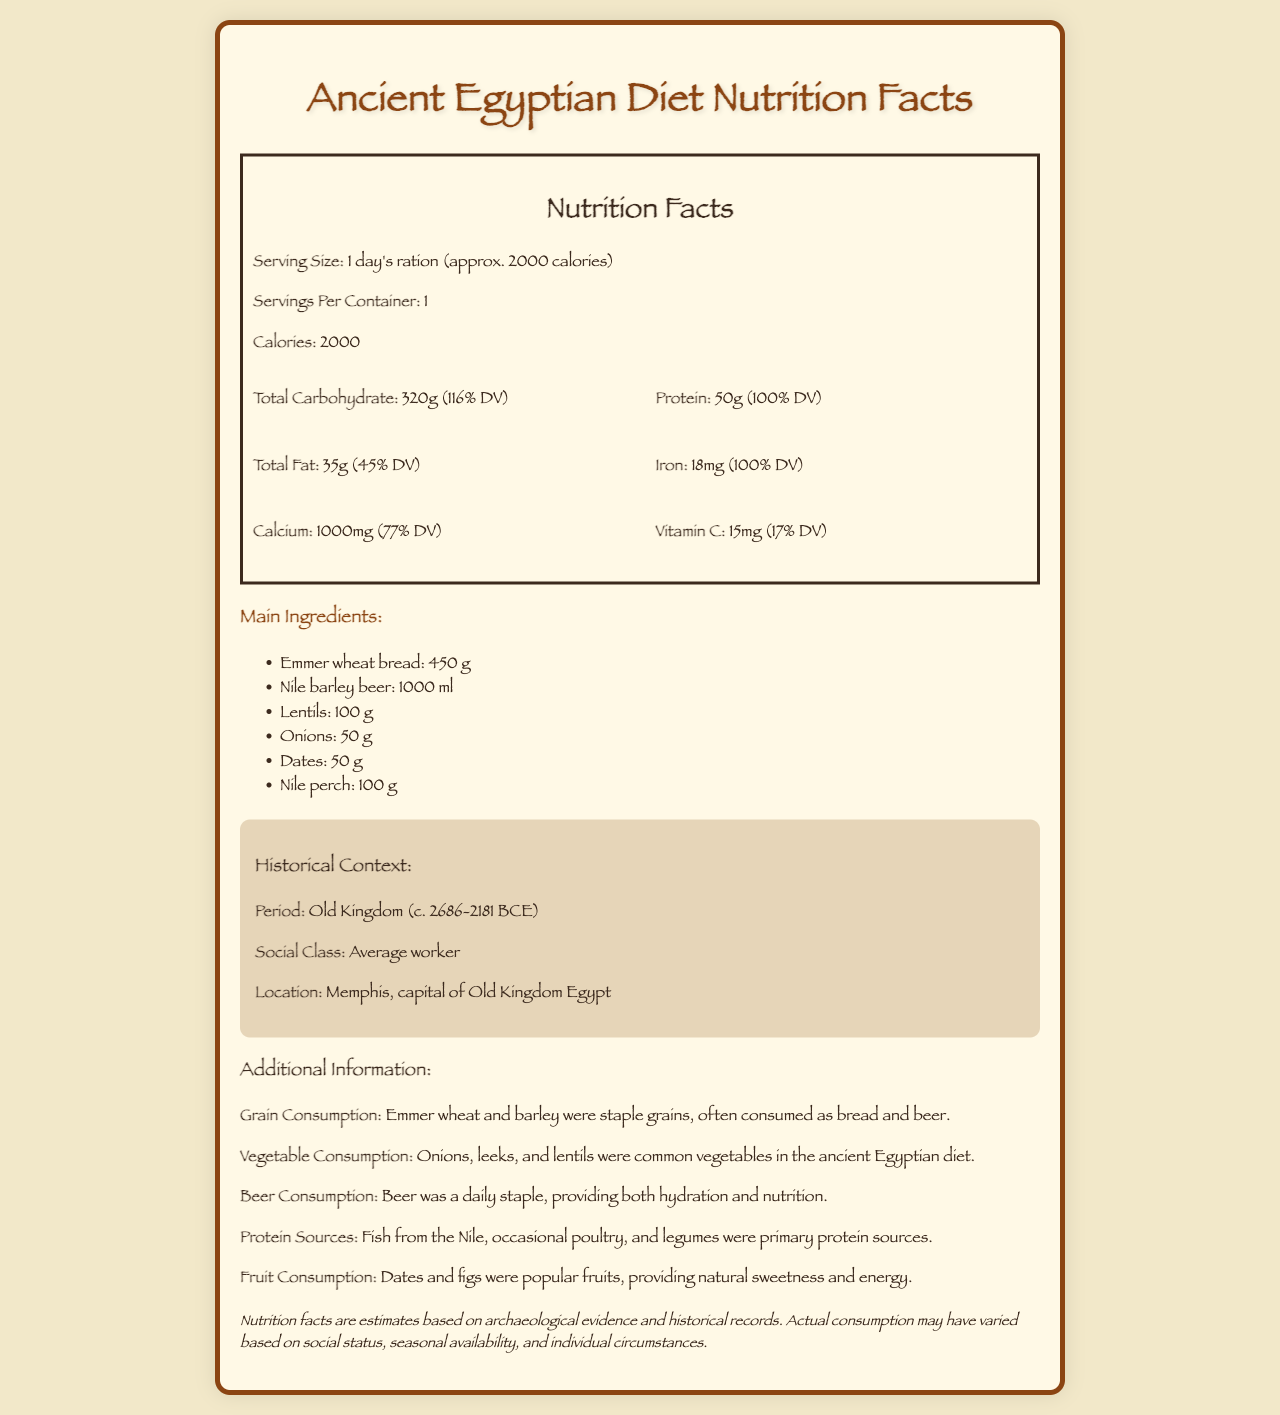who is the intended social class for this diet? The historical context section of the document specifies that this diet is for the "Average worker."
Answer: Average worker what is the serving size stated in the nutrition facts? The nutrition facts section at the top of the document mentions that the serving size is "1 day's ration (approx. 2000 calories)."
Answer: 1 day's ration (approx. 2000 calories) how much total carbohydrate is in one serving? The nutrition facts section lists the total carbohydrate content as "320 g."
Answer: 320 g what are the main protein sources mentioned? The additional information section specifies the primary protein sources as "Fish from the Nile, occasional poultry, and legumes."
Answer: Fish from the Nile, occasional poultry, and legumes which vegetable is included in the main ingredients? The ingredients list includes "Onions: 50 g."
Answer: Onions what percentage of the daily value for iron is provided by this diet? The nutrition facts section shows that the iron content in one serving is "18 mg," which is 100% of the daily value.
Answer: 100% how much beer was consumed in the Old Kingdom period according to the document? A. 500 ml B. 1000 ml C. 1500 ml The main ingredients section lists "Nile barley beer: 1000 ml."
Answer: B what were popular fruits in the ancient Egyptian diet? A. Apples and bananas B. Dates and figs C. Oranges and grapes The additional information section mentions that "Dates and figs were popular fruits."
Answer: B how many grams of calcium are in one day's ration? A. 500 mg B. 750 mg C. 1000 mg The nutrition facts section shows that the calcium content is "1000 mg," which is 1 gram.
Answer: C was beer a common part of the daily diet in ancient Egypt? The additional information section states, "Beer was a daily staple."
Answer: Yes provide a summary of the document's main focus. The document outlines the nutrition of an ancient Egyptian worker's daily diet, including macronutrients and key ingredients, while placing the diet in a historical context.
Answer: The document provides a detailed nutrition facts label for an average worker's diet during the Old Kingdom period in ancient Egypt. It lists the serving size, nutritional content, main ingredients, and additional information on dietary habits, highlighting the central role of grains, vegetables, beer, and protein sources such as fish and legumes. how much lentils are included in the main ingredients? The ingredients list includes "Lentils: 100 g."
Answer: 100 g what period does the diet pertain to? The historical context section specifies that the diet pertains to the "Old Kingdom (c. 2686-2181 BCE)."
Answer: Old Kingdom (c. 2686-2181 BCE) is there information about seasonal variations in the diet? The document includes a disclaimer that actual consumption may have varied based on several factors, including seasonal availability, but does not provide specific information on seasonal variations.
Answer: No does this diet include Nile perch? The main ingredients section lists "Nile perch: 100 g."
Answer: Yes what percent of the daily value for vitamin C does one serving provide? The nutrition facts section shows that one serving provides "15 mg" of vitamin C, which is 17% of the daily value.
Answer: 17% what was a common use of grains in the ancient Egyptian diet? The additional information section indicates that grains like emmer wheat and barley were often consumed as "bread and beer."
Answer: Bread and beer 